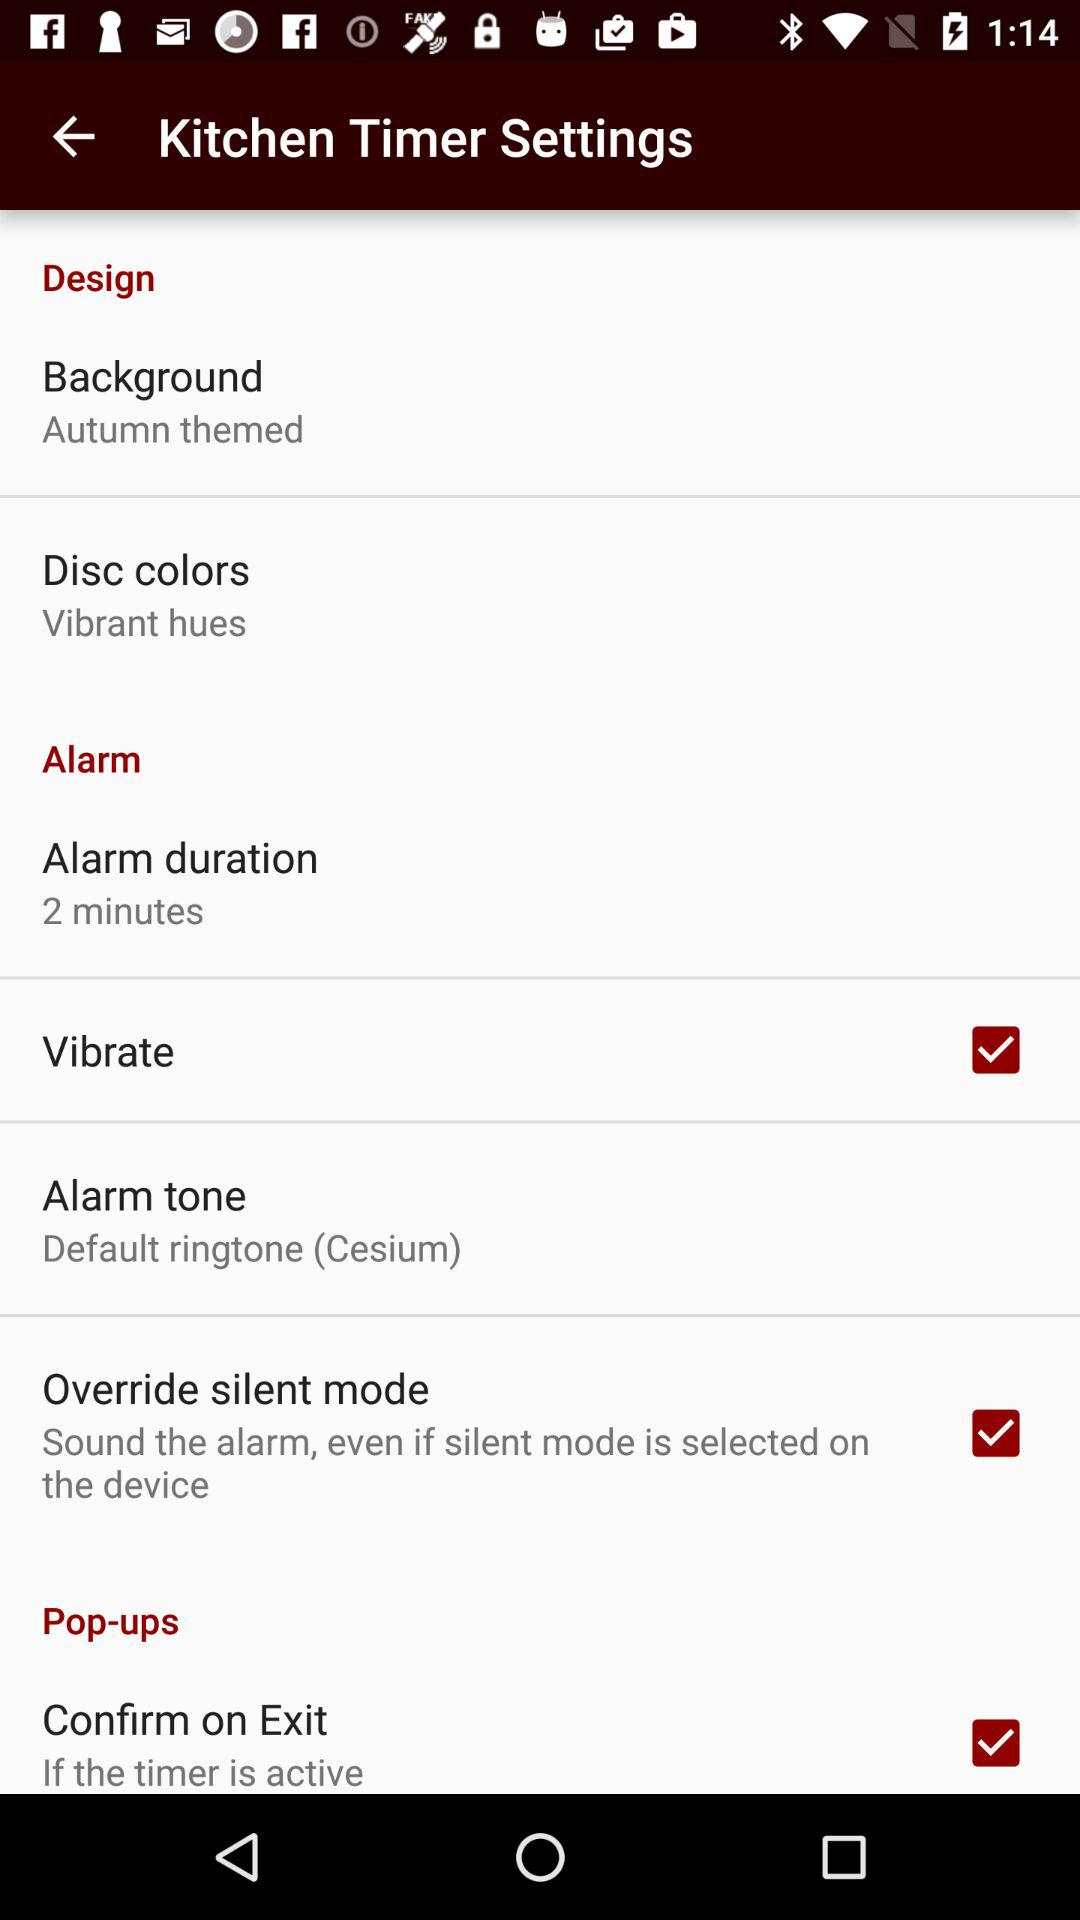What is the status of "Vibrate"? The status is "on". 